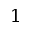<formula> <loc_0><loc_0><loc_500><loc_500>1</formula> 